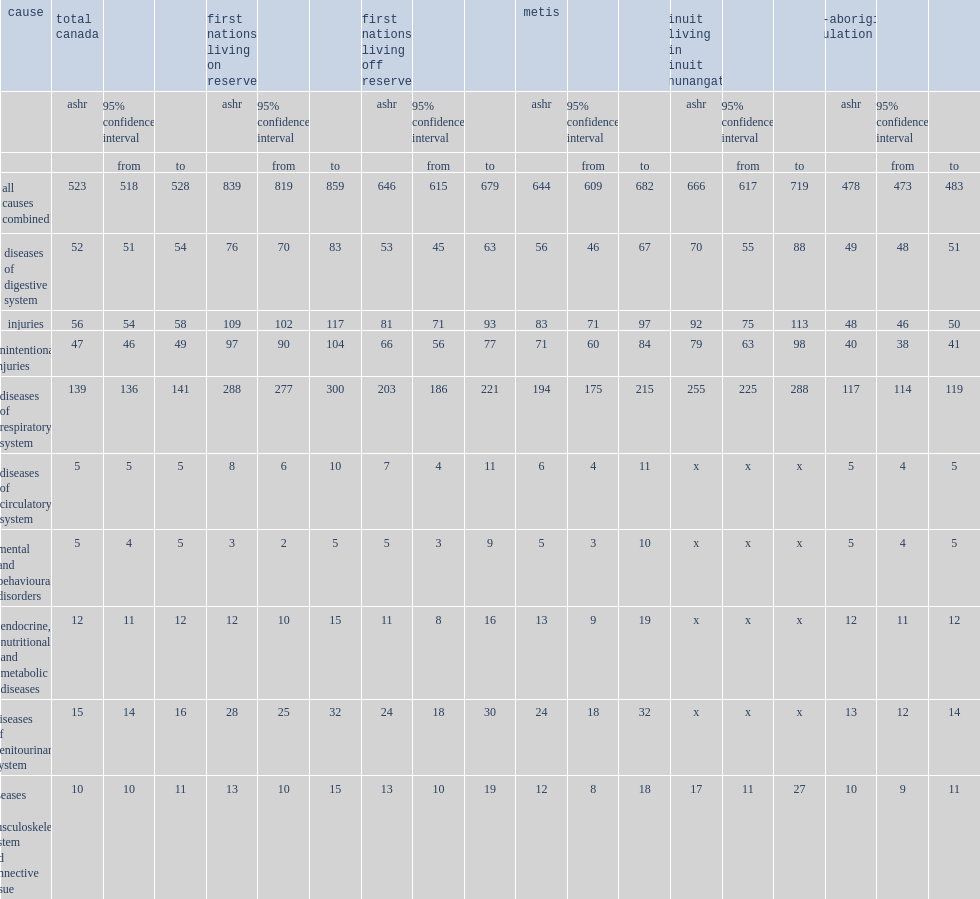At ages 0 to 9, how many times the overall hospitalization rate for first nations children living on reserve was that for non-aboriginal children ? 1.75523. At ages 0 to 9, how many times the overall hospitalization rate for first nations living off reserve was that for non-aboriginal children ? 1.351464. At ages 0 to 9, how many times the overall hospitalization rate for metis was that for non-aboriginal children ? 1.34728. At ages 0 to 9, how many times the overall hospitalization rate for inuit in inuit nunangat was that for non-aboriginal children ? 1.393305. 